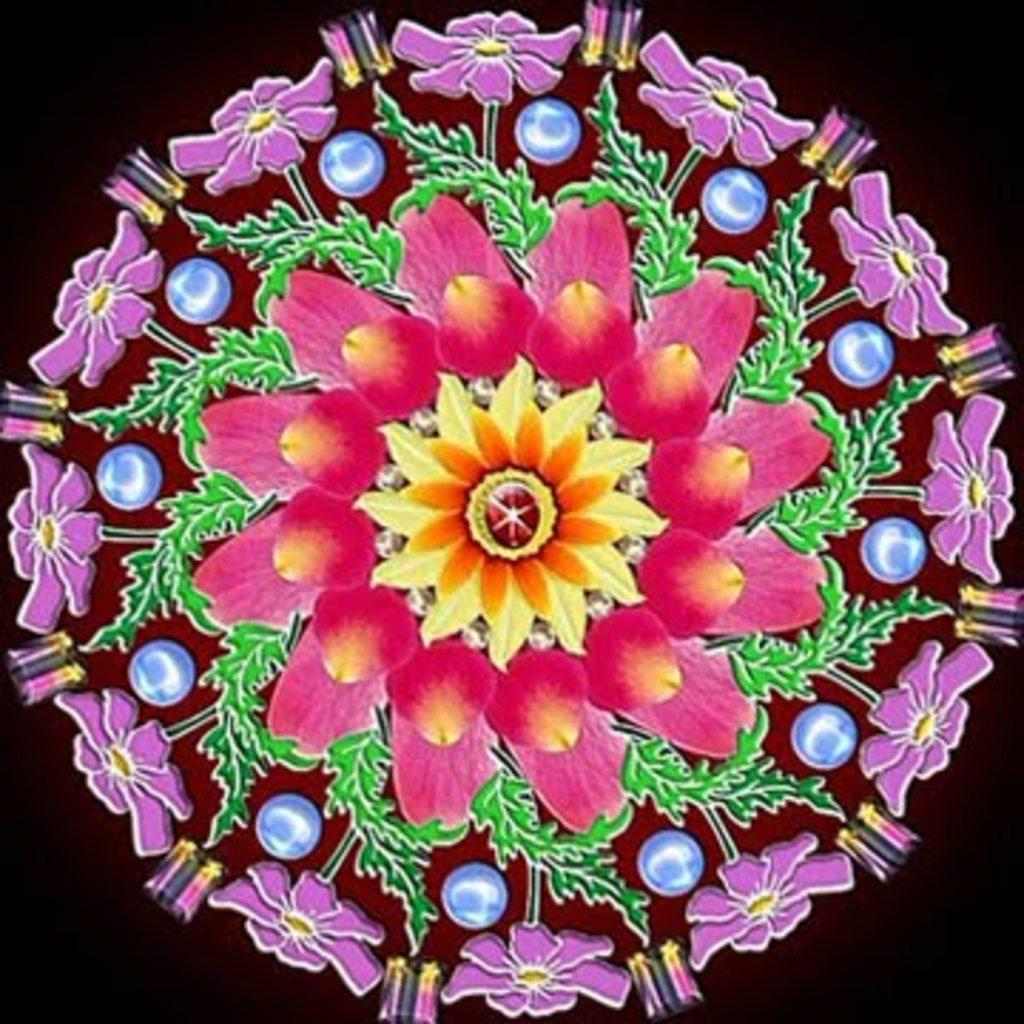What is the main feature of the image? There is a colorful design in the center of the image. What elements are included in the design? The design includes flowers and other objects. How would you describe the background of the image? The background of the image is blurred. How many women are wearing skirts in the image? There are no women or skirts present in the image; it features a colorful design with flowers and other objects. 